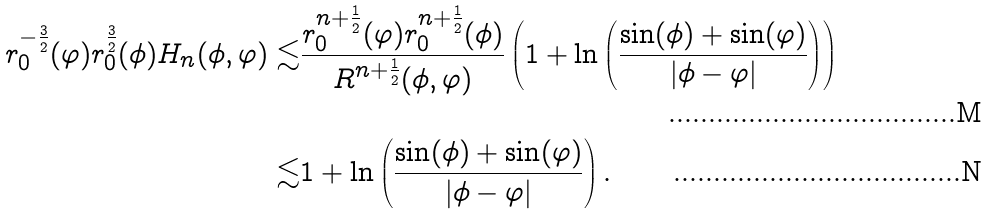Convert formula to latex. <formula><loc_0><loc_0><loc_500><loc_500>r _ { 0 } ^ { - \frac { 3 } { 2 } } ( \varphi ) { r _ { 0 } ^ { \frac { 3 } { 2 } } ( \phi ) } H _ { n } ( \phi , \varphi ) \lesssim & \frac { r _ { 0 } ^ { n + \frac { 1 } { 2 } } ( \varphi ) r _ { 0 } ^ { n + \frac { 1 } { 2 } } ( \phi ) } { R ^ { n + \frac { 1 } { 2 } } ( \phi , \varphi ) } \left ( 1 + \ln \left ( \frac { \sin ( \phi ) + \sin ( \varphi ) } { | \phi - \varphi | } \right ) \right ) \\ \lesssim & 1 + \ln \left ( \frac { \sin ( \phi ) + \sin ( \varphi ) } { | \phi - \varphi | } \right ) .</formula> 